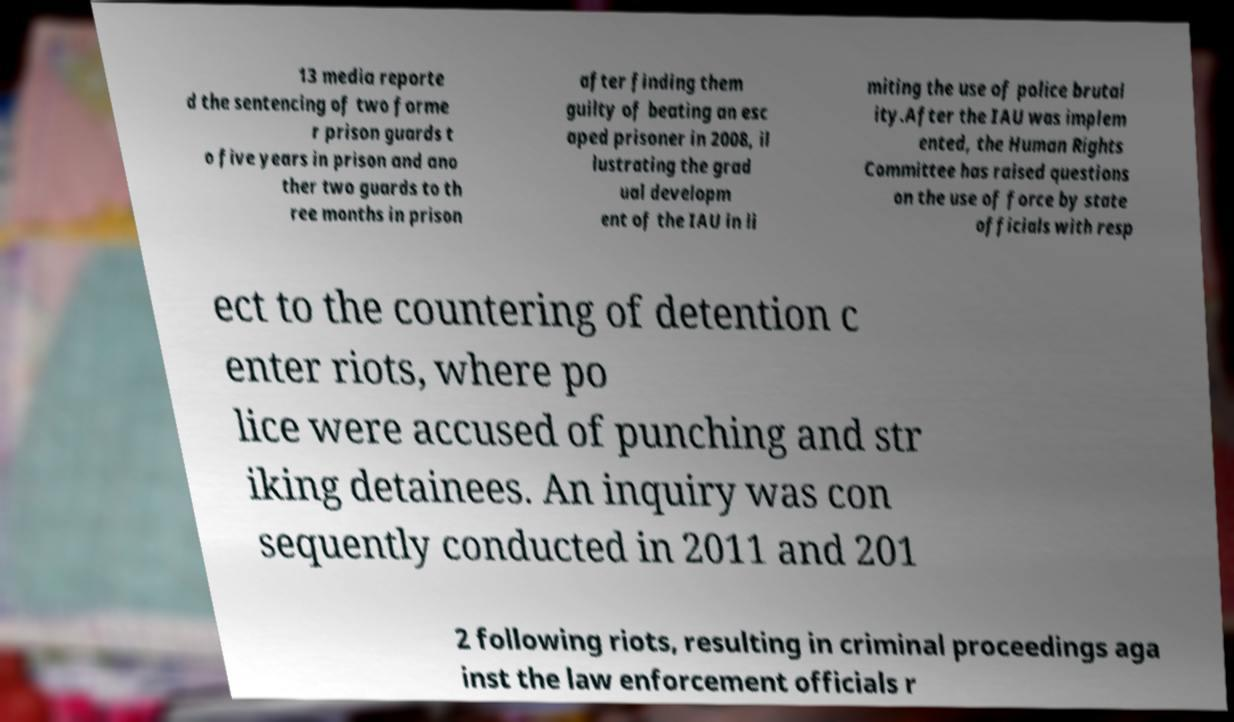Please read and relay the text visible in this image. What does it say? 13 media reporte d the sentencing of two forme r prison guards t o five years in prison and ano ther two guards to th ree months in prison after finding them guilty of beating an esc aped prisoner in 2008, il lustrating the grad ual developm ent of the IAU in li miting the use of police brutal ity.After the IAU was implem ented, the Human Rights Committee has raised questions on the use of force by state officials with resp ect to the countering of detention c enter riots, where po lice were accused of punching and str iking detainees. An inquiry was con sequently conducted in 2011 and 201 2 following riots, resulting in criminal proceedings aga inst the law enforcement officials r 